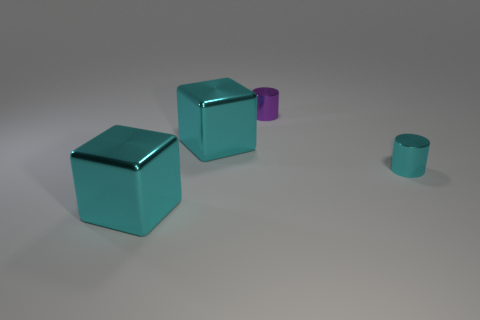What is the material of the thing that is both behind the cyan cylinder and left of the purple metal cylinder?
Offer a very short reply. Metal. What number of other small shiny objects are the same shape as the small cyan metallic object?
Your answer should be very brief. 1. There is a cube that is behind the tiny shiny thing right of the small purple metallic thing; what color is it?
Keep it short and to the point. Cyan. Are there an equal number of large shiny objects that are behind the small cyan metal cylinder and small green cylinders?
Offer a terse response. No. Is there a cube that has the same size as the purple metal object?
Your response must be concise. No. There is a purple cylinder; is its size the same as the thing to the right of the purple shiny cylinder?
Your response must be concise. Yes. Are there an equal number of cylinders that are behind the tiny cyan shiny object and purple cylinders that are on the right side of the purple shiny cylinder?
Give a very brief answer. No. There is a small cylinder that is in front of the purple object; what is its material?
Your answer should be very brief. Metal. Is the purple cylinder the same size as the cyan shiny cylinder?
Provide a succinct answer. Yes. Are there more small things right of the small cyan cylinder than cyan shiny objects?
Your response must be concise. No. 